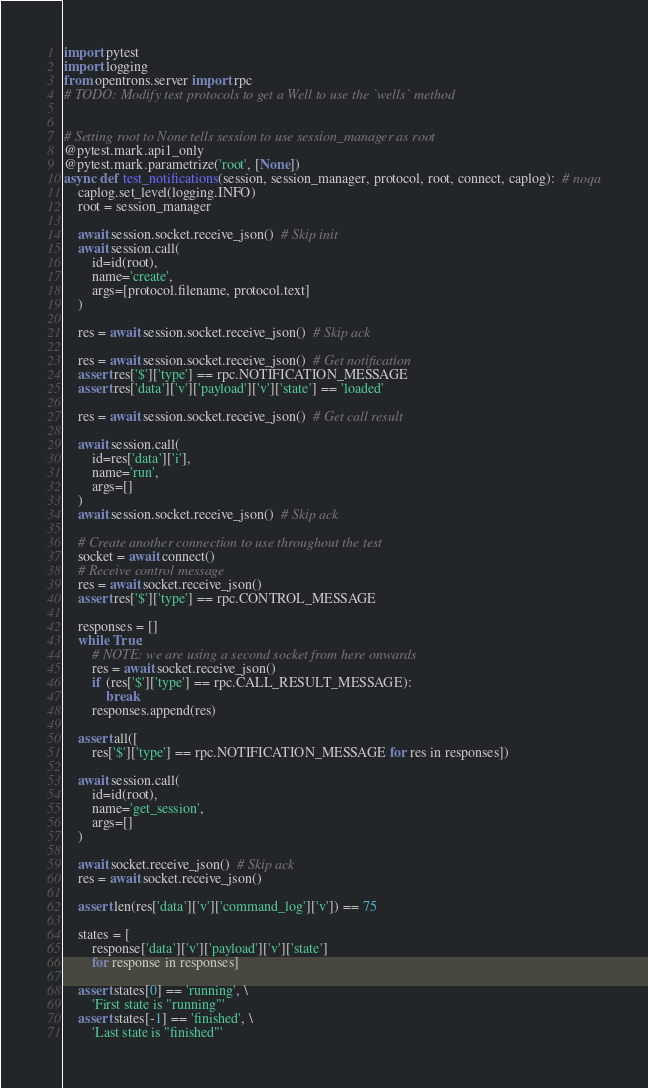<code> <loc_0><loc_0><loc_500><loc_500><_Python_>import pytest
import logging
from opentrons.server import rpc
# TODO: Modify test protocols to get a Well to use the `wells` method


# Setting root to None tells session to use session_manager as root
@pytest.mark.api1_only
@pytest.mark.parametrize('root', [None])
async def test_notifications(session, session_manager, protocol, root, connect, caplog):  # noqa
    caplog.set_level(logging.INFO)
    root = session_manager

    await session.socket.receive_json()  # Skip init
    await session.call(
        id=id(root),
        name='create',
        args=[protocol.filename, protocol.text]
    )

    res = await session.socket.receive_json()  # Skip ack

    res = await session.socket.receive_json()  # Get notification
    assert res['$']['type'] == rpc.NOTIFICATION_MESSAGE
    assert res['data']['v']['payload']['v']['state'] == 'loaded'

    res = await session.socket.receive_json()  # Get call result

    await session.call(
        id=res['data']['i'],
        name='run',
        args=[]
    )
    await session.socket.receive_json()  # Skip ack

    # Create another connection to use throughout the test
    socket = await connect()
    # Receive control message
    res = await socket.receive_json()
    assert res['$']['type'] == rpc.CONTROL_MESSAGE

    responses = []
    while True:
        # NOTE: we are using a second socket from here onwards
        res = await socket.receive_json()
        if (res['$']['type'] == rpc.CALL_RESULT_MESSAGE):
            break
        responses.append(res)

    assert all([
        res['$']['type'] == rpc.NOTIFICATION_MESSAGE for res in responses])

    await session.call(
        id=id(root),
        name='get_session',
        args=[]
    )

    await socket.receive_json()  # Skip ack
    res = await socket.receive_json()

    assert len(res['data']['v']['command_log']['v']) == 75

    states = [
        response['data']['v']['payload']['v']['state']
        for response in responses]

    assert states[0] == 'running', \
        'First state is "running"'
    assert states[-1] == 'finished', \
        'Last state is "finished"'
</code> 